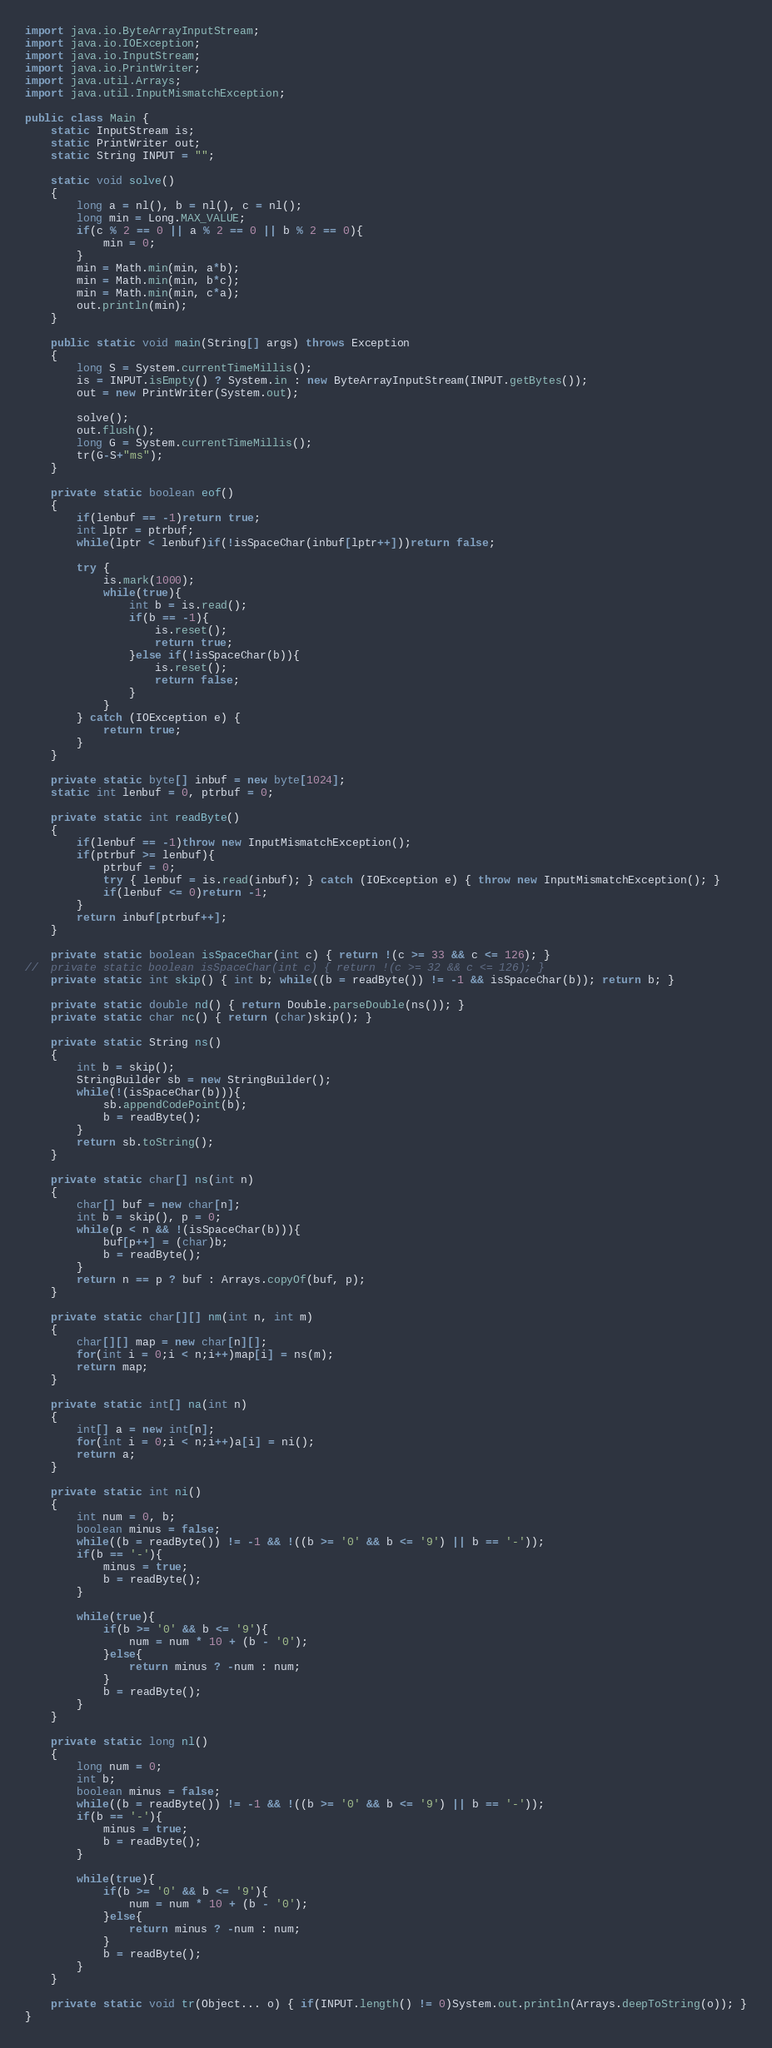Convert code to text. <code><loc_0><loc_0><loc_500><loc_500><_Java_>import java.io.ByteArrayInputStream;
import java.io.IOException;
import java.io.InputStream;
import java.io.PrintWriter;
import java.util.Arrays;
import java.util.InputMismatchException;

public class Main {
	static InputStream is;
	static PrintWriter out;
	static String INPUT = "";
	
	static void solve()
	{
		long a = nl(), b = nl(), c = nl();
		long min = Long.MAX_VALUE;
		if(c % 2 == 0 || a % 2 == 0 || b % 2 == 0){
			min = 0;
		}
		min = Math.min(min, a*b);
		min = Math.min(min, b*c);
		min = Math.min(min, c*a);
		out.println(min);
	}
	
	public static void main(String[] args) throws Exception
	{
		long S = System.currentTimeMillis();
		is = INPUT.isEmpty() ? System.in : new ByteArrayInputStream(INPUT.getBytes());
		out = new PrintWriter(System.out);
		
		solve();
		out.flush();
		long G = System.currentTimeMillis();
		tr(G-S+"ms");
	}
	
	private static boolean eof()
	{
		if(lenbuf == -1)return true;
		int lptr = ptrbuf;
		while(lptr < lenbuf)if(!isSpaceChar(inbuf[lptr++]))return false;
		
		try {
			is.mark(1000);
			while(true){
				int b = is.read();
				if(b == -1){
					is.reset();
					return true;
				}else if(!isSpaceChar(b)){
					is.reset();
					return false;
				}
			}
		} catch (IOException e) {
			return true;
		}
	}
	
	private static byte[] inbuf = new byte[1024];
	static int lenbuf = 0, ptrbuf = 0;
	
	private static int readByte()
	{
		if(lenbuf == -1)throw new InputMismatchException();
		if(ptrbuf >= lenbuf){
			ptrbuf = 0;
			try { lenbuf = is.read(inbuf); } catch (IOException e) { throw new InputMismatchException(); }
			if(lenbuf <= 0)return -1;
		}
		return inbuf[ptrbuf++];
	}
	
	private static boolean isSpaceChar(int c) { return !(c >= 33 && c <= 126); }
//	private static boolean isSpaceChar(int c) { return !(c >= 32 && c <= 126); }
	private static int skip() { int b; while((b = readByte()) != -1 && isSpaceChar(b)); return b; }
	
	private static double nd() { return Double.parseDouble(ns()); }
	private static char nc() { return (char)skip(); }
	
	private static String ns()
	{
		int b = skip();
		StringBuilder sb = new StringBuilder();
		while(!(isSpaceChar(b))){
			sb.appendCodePoint(b);
			b = readByte();
		}
		return sb.toString();
	}
	
	private static char[] ns(int n)
	{
		char[] buf = new char[n];
		int b = skip(), p = 0;
		while(p < n && !(isSpaceChar(b))){
			buf[p++] = (char)b;
			b = readByte();
		}
		return n == p ? buf : Arrays.copyOf(buf, p);
	}
	
	private static char[][] nm(int n, int m)
	{
		char[][] map = new char[n][];
		for(int i = 0;i < n;i++)map[i] = ns(m);
		return map;
	}
	
	private static int[] na(int n)
	{
		int[] a = new int[n];
		for(int i = 0;i < n;i++)a[i] = ni();
		return a;
	}
	
	private static int ni()
	{
		int num = 0, b;
		boolean minus = false;
		while((b = readByte()) != -1 && !((b >= '0' && b <= '9') || b == '-'));
		if(b == '-'){
			minus = true;
			b = readByte();
		}
		
		while(true){
			if(b >= '0' && b <= '9'){
				num = num * 10 + (b - '0');
			}else{
				return minus ? -num : num;
			}
			b = readByte();
		}
	}
	
	private static long nl()
	{
		long num = 0;
		int b;
		boolean minus = false;
		while((b = readByte()) != -1 && !((b >= '0' && b <= '9') || b == '-'));
		if(b == '-'){
			minus = true;
			b = readByte();
		}
		
		while(true){
			if(b >= '0' && b <= '9'){
				num = num * 10 + (b - '0');
			}else{
				return minus ? -num : num;
			}
			b = readByte();
		}
	}
	
	private static void tr(Object... o) { if(INPUT.length() != 0)System.out.println(Arrays.deepToString(o)); }
}
</code> 